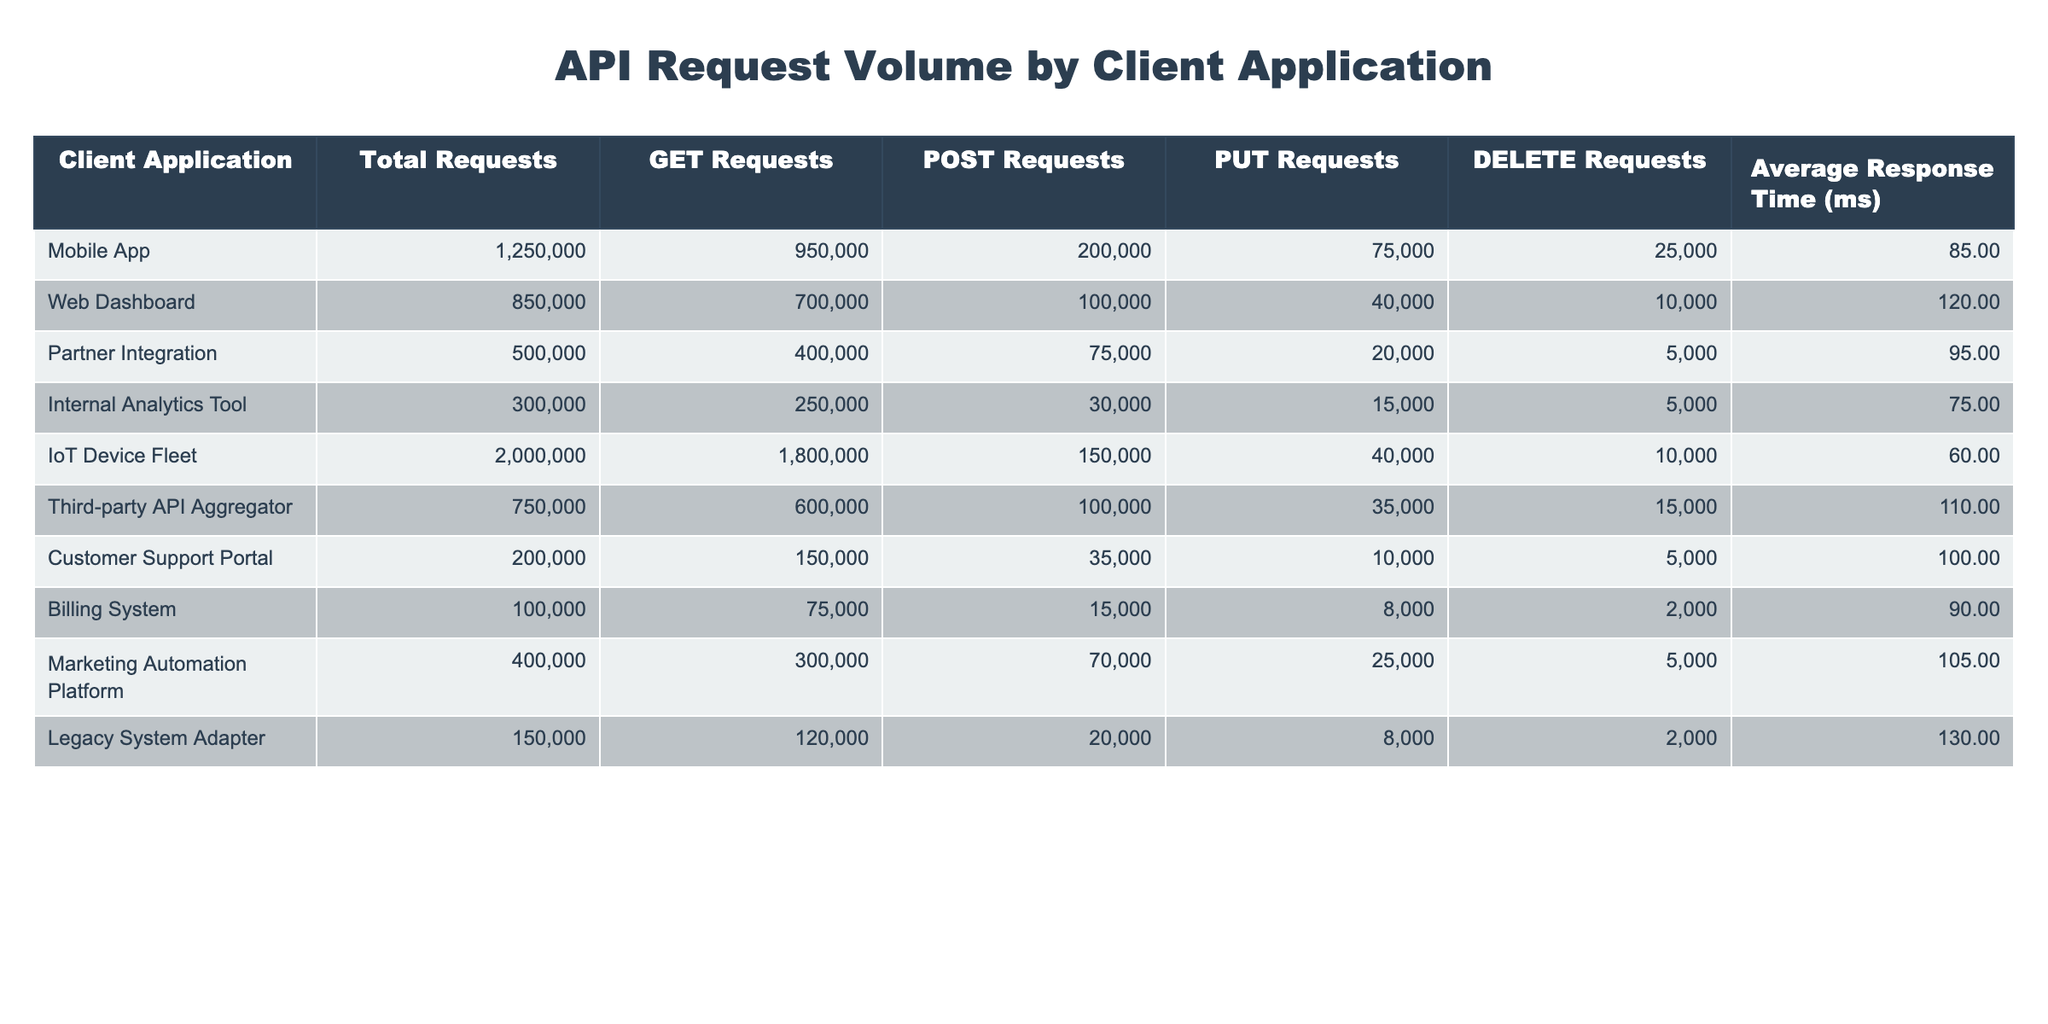What is the total number of requests made by the Mobile App? The table shows that the total requests for the Mobile App is listed directly under the "Total Requests" column. It states 1,250,000.
Answer: 1,250,000 Which client application has the highest number of GET requests? By examining the "GET Requests" column, the IoT Device Fleet has the highest number with 1,800,000 requests.
Answer: IoT Device Fleet What percentage of requests made by the Customer Support Portal are POST requests? The total requests for the Customer Support Portal are 200,000, and the POST requests are 35,000. The percentage can be calculated as (35,000 / 200,000) * 100 = 17.5%.
Answer: 17.5% Which client application has the lowest average response time? The table provides the average response times, and the IoT Device Fleet has the lowest at 60 ms.
Answer: IoT Device Fleet How many more DELETE requests does the Web Dashboard have compared to the Partner Integration? The Web Dashboard has 10,000 DELETE requests and the Partner Integration has 5,000. The difference is 10,000 - 5,000 = 5,000.
Answer: 5,000 Are the average response times for the Mobile App and the Web Dashboard the same? The average response time for the Mobile App is 85 ms and for the Web Dashboard is 120 ms. Since they are different values, the answer is no.
Answer: No What is the sum of all POST requests across all client applications? The POST requests are: 200,000 (Mobile App) + 100,000 (Web Dashboard) + 75,000 (Partner Integration) + 30,000 (Internal Analytics Tool) + 150,000 (IoT Device Fleet) + 100,000 (Third-party API Aggregator) + 35,000 (Customer Support Portal) + 15,000 (Billing System) + 70,000 (Marketing Automation Platform) + 20,000 (Legacy System Adapter) = 1,180,000.
Answer: 1,180,000 Which client applications have a total request count greater than 500,000? By comparing the total requests in the table, the Mobile App (1,250,000), IoT Device Fleet (2,000,000), and Web Dashboard (850,000) all exceed 500,000.
Answer: Mobile App, IoT Device Fleet, Web Dashboard What is the average response time for client applications that use POST requests? The average response time can be calculated by averaging the corresponding response times of Mobile App (85), Web Dashboard (120), Partner Integration (95), Internal Analytics Tool (75), IoT Device Fleet (60), Third-party API Aggregator (110), Customer Support Portal (100), Billing System (90), Marketing Automation Platform (105), and Legacy System Adapter (130). This gives a sum of 1,025 and dividing by 10 results in 102.5 ms.
Answer: 102.5 ms Is the total number of GET requests for the Internal Analytics Tool greater than the total number of POST requests for the Mobile App? The Internal Analytics Tool has 250,000 GET requests, and the Mobile App has 200,000 POST requests. Since 250,000 is greater than 200,000, the answer is yes.
Answer: Yes How does the average response time of the Billing System compare to that of the Marketing Automation Platform? The average response time for the Billing System is 90 ms, and for the Marketing Automation Platform, it is 105 ms. Since 90 ms is less than 105 ms, the average response time for Billing System is lower.
Answer: Lower 